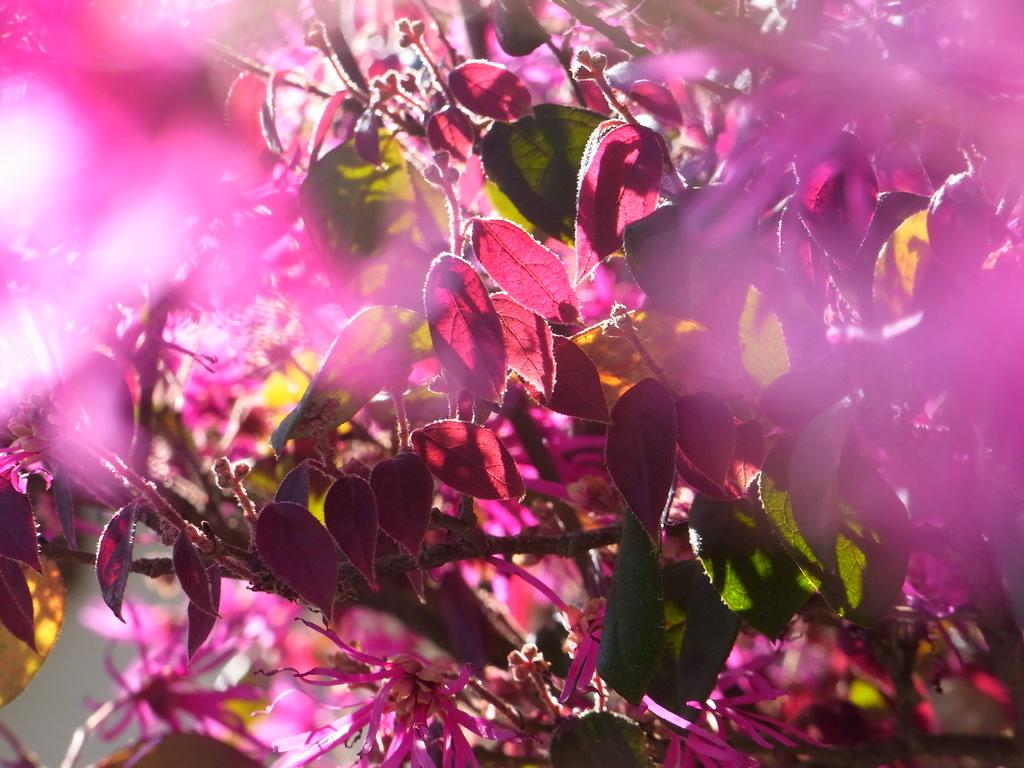What type of vegetation can be seen in the image? There are leaves in the image. Can you describe the color of the leaves? The leaves are in pink and green color. What other floral elements are present in the image? There are flowers in the image. What is the color of the flowers? The flowers are in pink color. What type of scarf can be seen wrapped around the flowers in the image? There is no scarf present in the image; it only features leaves and flowers. How does the beef appear in the image? There is no beef present in the image. 